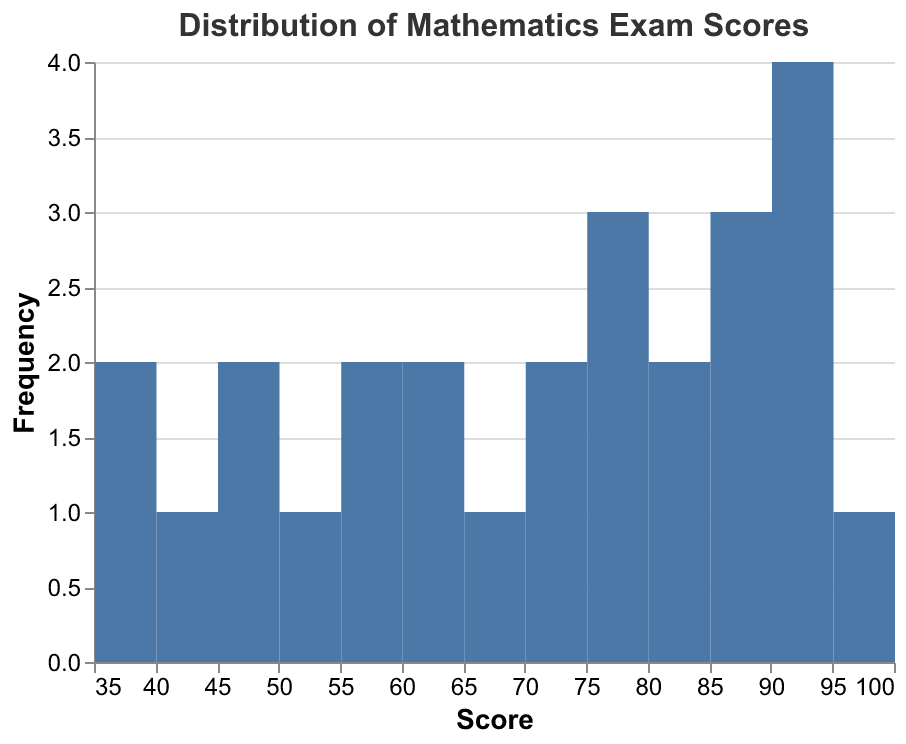What is the title of the figure? The title is displayed at the top of the figure.
Answer: Distribution of Mathematics Exam Scores How many students scored above 90? Observing the bars higher than the score of 90 and counting them, we see bars at 92, 93, 94, and 96.
Answer: 4 What is the range of scores in the distplot? The x-axis represents the scores ranging from the minimum to maximum observed, which spans from 38 to 96
Answer: 38 to 96 Which score has the highest frequency? The tallest bar represents the score category with the highest count of students. The bar at 92 corresponds to the highest frequency.
Answer: 92 Compare the number of students who scored below 50 and those who scored above 80. Which group has more students? Counting students from the bar segments, we find the number of students below 50 and those above 80. Below 50: 38, 39, 44, 45, 49 (5 students); above 80: 81, 82, 85, 86, 88, 90, 92, 93, 94, 96 (10 students). The group above 80 is larger.
Answer: Above 80 What is the total number of students represented in the distplot? Count the total frequency of all the bars combined, which represents the total number of data points. There are 26 students in total.
Answer: 26 Calculate the average score of the students represented in the distplot. The average score can be found by summing all individual scores (45 + 78 + 82 + 92 + 68 + 55 + 39 + 73 + 88 + 94 + 60 + 49 + 85 + 52 + 96 + 70 + 63 + 77 + 81 + 44 + 93 + 38 + 59 + 86 + 76 + 90) which equals 1784, then dividing by the total number of students (26). Average score = 1784 / 26
Answer: 68.62 How many students scored in the range of 60 to 80? By counting the bars that fall between the scores of 60 and 80, we find the values within the range 60, 63, 68, 70, 73, 76, 77, 78 (total: 8 students).
Answer: 8 